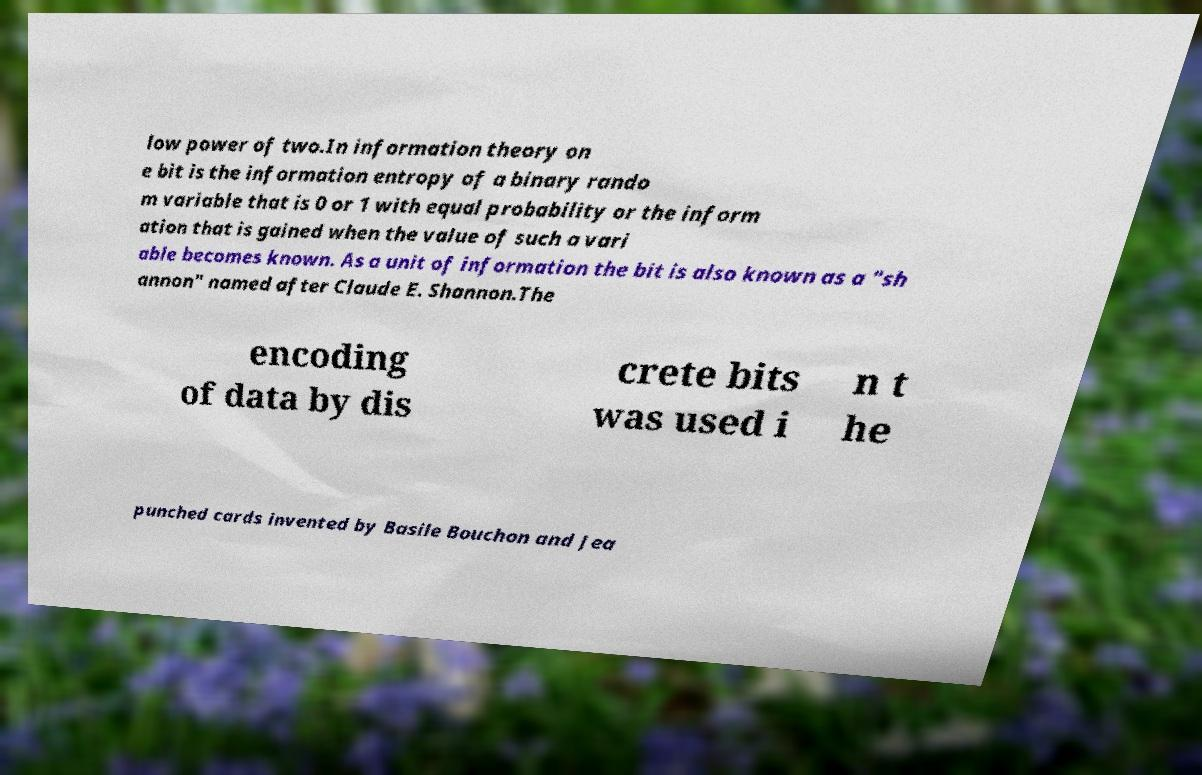Could you extract and type out the text from this image? low power of two.In information theory on e bit is the information entropy of a binary rando m variable that is 0 or 1 with equal probability or the inform ation that is gained when the value of such a vari able becomes known. As a unit of information the bit is also known as a "sh annon" named after Claude E. Shannon.The encoding of data by dis crete bits was used i n t he punched cards invented by Basile Bouchon and Jea 